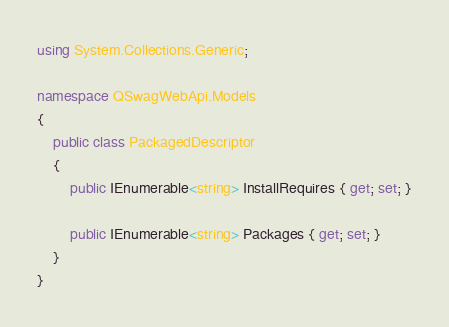Convert code to text. <code><loc_0><loc_0><loc_500><loc_500><_C#_>using System.Collections.Generic;

namespace QSwagWebApi.Models
{
    public class PackagedDescriptor
    {
        public IEnumerable<string> InstallRequires { get; set; }

        public IEnumerable<string> Packages { get; set; }
    }
}
</code> 